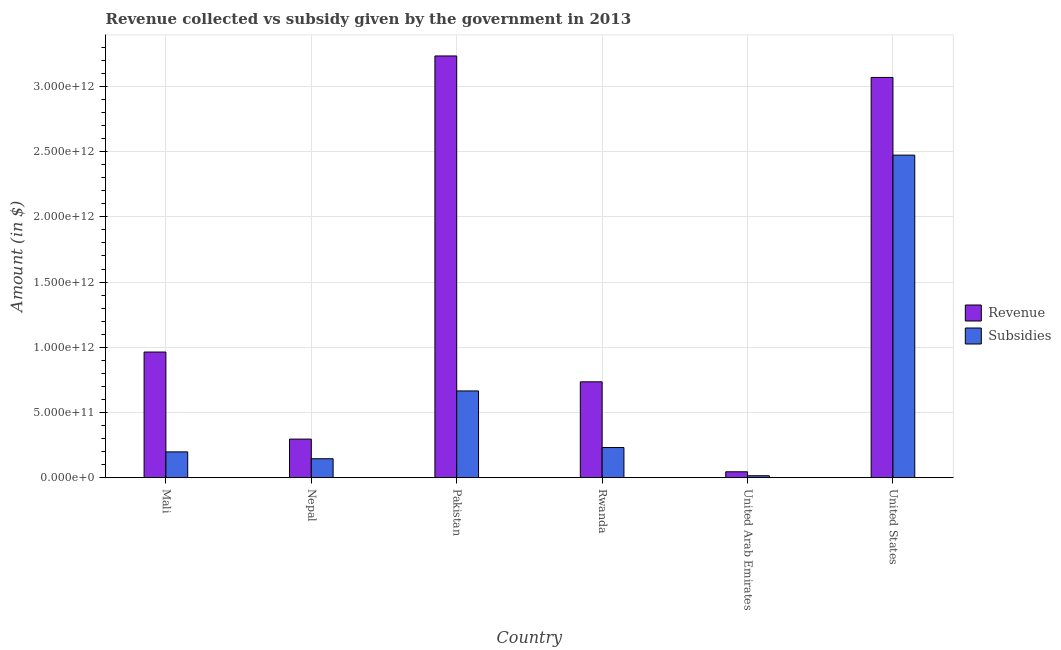How many different coloured bars are there?
Your answer should be compact. 2. How many groups of bars are there?
Ensure brevity in your answer.  6. Are the number of bars per tick equal to the number of legend labels?
Make the answer very short. Yes. Are the number of bars on each tick of the X-axis equal?
Keep it short and to the point. Yes. How many bars are there on the 1st tick from the left?
Your response must be concise. 2. How many bars are there on the 5th tick from the right?
Your answer should be very brief. 2. What is the label of the 1st group of bars from the left?
Your response must be concise. Mali. In how many cases, is the number of bars for a given country not equal to the number of legend labels?
Offer a terse response. 0. What is the amount of revenue collected in Nepal?
Your response must be concise. 2.96e+11. Across all countries, what is the maximum amount of subsidies given?
Your answer should be compact. 2.47e+12. Across all countries, what is the minimum amount of subsidies given?
Your answer should be very brief. 1.47e+1. In which country was the amount of revenue collected minimum?
Provide a short and direct response. United Arab Emirates. What is the total amount of revenue collected in the graph?
Provide a succinct answer. 8.34e+12. What is the difference between the amount of revenue collected in Mali and that in Rwanda?
Offer a terse response. 2.28e+11. What is the difference between the amount of revenue collected in Mali and the amount of subsidies given in Pakistan?
Offer a very short reply. 2.98e+11. What is the average amount of revenue collected per country?
Keep it short and to the point. 1.39e+12. What is the difference between the amount of revenue collected and amount of subsidies given in United Arab Emirates?
Ensure brevity in your answer.  3.02e+1. In how many countries, is the amount of subsidies given greater than 900000000000 $?
Ensure brevity in your answer.  1. What is the ratio of the amount of revenue collected in Pakistan to that in United Arab Emirates?
Provide a short and direct response. 72.01. Is the amount of revenue collected in Pakistan less than that in United Arab Emirates?
Provide a succinct answer. No. What is the difference between the highest and the second highest amount of subsidies given?
Ensure brevity in your answer.  1.81e+12. What is the difference between the highest and the lowest amount of revenue collected?
Ensure brevity in your answer.  3.19e+12. Is the sum of the amount of subsidies given in Nepal and United States greater than the maximum amount of revenue collected across all countries?
Make the answer very short. No. What does the 2nd bar from the left in Nepal represents?
Your answer should be very brief. Subsidies. What does the 1st bar from the right in Rwanda represents?
Ensure brevity in your answer.  Subsidies. Are all the bars in the graph horizontal?
Offer a terse response. No. What is the difference between two consecutive major ticks on the Y-axis?
Give a very brief answer. 5.00e+11. Are the values on the major ticks of Y-axis written in scientific E-notation?
Your answer should be compact. Yes. Where does the legend appear in the graph?
Ensure brevity in your answer.  Center right. How are the legend labels stacked?
Make the answer very short. Vertical. What is the title of the graph?
Make the answer very short. Revenue collected vs subsidy given by the government in 2013. Does "Domestic Liabilities" appear as one of the legend labels in the graph?
Provide a short and direct response. No. What is the label or title of the X-axis?
Your response must be concise. Country. What is the label or title of the Y-axis?
Give a very brief answer. Amount (in $). What is the Amount (in $) of Revenue in Mali?
Your answer should be very brief. 9.63e+11. What is the Amount (in $) in Subsidies in Mali?
Ensure brevity in your answer.  1.98e+11. What is the Amount (in $) of Revenue in Nepal?
Your response must be concise. 2.96e+11. What is the Amount (in $) in Subsidies in Nepal?
Give a very brief answer. 1.45e+11. What is the Amount (in $) of Revenue in Pakistan?
Provide a succinct answer. 3.23e+12. What is the Amount (in $) in Subsidies in Pakistan?
Make the answer very short. 6.65e+11. What is the Amount (in $) of Revenue in Rwanda?
Your answer should be very brief. 7.35e+11. What is the Amount (in $) in Subsidies in Rwanda?
Make the answer very short. 2.31e+11. What is the Amount (in $) in Revenue in United Arab Emirates?
Give a very brief answer. 4.49e+1. What is the Amount (in $) in Subsidies in United Arab Emirates?
Your response must be concise. 1.47e+1. What is the Amount (in $) of Revenue in United States?
Give a very brief answer. 3.07e+12. What is the Amount (in $) in Subsidies in United States?
Your response must be concise. 2.47e+12. Across all countries, what is the maximum Amount (in $) of Revenue?
Your answer should be very brief. 3.23e+12. Across all countries, what is the maximum Amount (in $) of Subsidies?
Give a very brief answer. 2.47e+12. Across all countries, what is the minimum Amount (in $) of Revenue?
Provide a short and direct response. 4.49e+1. Across all countries, what is the minimum Amount (in $) in Subsidies?
Your answer should be very brief. 1.47e+1. What is the total Amount (in $) in Revenue in the graph?
Provide a succinct answer. 8.34e+12. What is the total Amount (in $) in Subsidies in the graph?
Provide a succinct answer. 3.73e+12. What is the difference between the Amount (in $) of Revenue in Mali and that in Nepal?
Provide a succinct answer. 6.68e+11. What is the difference between the Amount (in $) in Subsidies in Mali and that in Nepal?
Offer a terse response. 5.27e+1. What is the difference between the Amount (in $) in Revenue in Mali and that in Pakistan?
Make the answer very short. -2.27e+12. What is the difference between the Amount (in $) of Subsidies in Mali and that in Pakistan?
Keep it short and to the point. -4.67e+11. What is the difference between the Amount (in $) of Revenue in Mali and that in Rwanda?
Your response must be concise. 2.28e+11. What is the difference between the Amount (in $) of Subsidies in Mali and that in Rwanda?
Provide a succinct answer. -3.32e+1. What is the difference between the Amount (in $) of Revenue in Mali and that in United Arab Emirates?
Your answer should be very brief. 9.18e+11. What is the difference between the Amount (in $) of Subsidies in Mali and that in United Arab Emirates?
Provide a short and direct response. 1.83e+11. What is the difference between the Amount (in $) of Revenue in Mali and that in United States?
Your answer should be very brief. -2.11e+12. What is the difference between the Amount (in $) of Subsidies in Mali and that in United States?
Give a very brief answer. -2.28e+12. What is the difference between the Amount (in $) in Revenue in Nepal and that in Pakistan?
Provide a succinct answer. -2.94e+12. What is the difference between the Amount (in $) in Subsidies in Nepal and that in Pakistan?
Make the answer very short. -5.20e+11. What is the difference between the Amount (in $) of Revenue in Nepal and that in Rwanda?
Offer a terse response. -4.39e+11. What is the difference between the Amount (in $) in Subsidies in Nepal and that in Rwanda?
Your answer should be very brief. -8.59e+1. What is the difference between the Amount (in $) of Revenue in Nepal and that in United Arab Emirates?
Ensure brevity in your answer.  2.51e+11. What is the difference between the Amount (in $) of Subsidies in Nepal and that in United Arab Emirates?
Your answer should be very brief. 1.30e+11. What is the difference between the Amount (in $) in Revenue in Nepal and that in United States?
Your answer should be compact. -2.77e+12. What is the difference between the Amount (in $) of Subsidies in Nepal and that in United States?
Give a very brief answer. -2.33e+12. What is the difference between the Amount (in $) in Revenue in Pakistan and that in Rwanda?
Keep it short and to the point. 2.50e+12. What is the difference between the Amount (in $) of Subsidies in Pakistan and that in Rwanda?
Give a very brief answer. 4.34e+11. What is the difference between the Amount (in $) of Revenue in Pakistan and that in United Arab Emirates?
Make the answer very short. 3.19e+12. What is the difference between the Amount (in $) in Subsidies in Pakistan and that in United Arab Emirates?
Ensure brevity in your answer.  6.50e+11. What is the difference between the Amount (in $) of Revenue in Pakistan and that in United States?
Make the answer very short. 1.65e+11. What is the difference between the Amount (in $) of Subsidies in Pakistan and that in United States?
Provide a succinct answer. -1.81e+12. What is the difference between the Amount (in $) in Revenue in Rwanda and that in United Arab Emirates?
Keep it short and to the point. 6.90e+11. What is the difference between the Amount (in $) of Subsidies in Rwanda and that in United Arab Emirates?
Keep it short and to the point. 2.16e+11. What is the difference between the Amount (in $) of Revenue in Rwanda and that in United States?
Ensure brevity in your answer.  -2.33e+12. What is the difference between the Amount (in $) of Subsidies in Rwanda and that in United States?
Your response must be concise. -2.24e+12. What is the difference between the Amount (in $) in Revenue in United Arab Emirates and that in United States?
Give a very brief answer. -3.02e+12. What is the difference between the Amount (in $) of Subsidies in United Arab Emirates and that in United States?
Your response must be concise. -2.46e+12. What is the difference between the Amount (in $) in Revenue in Mali and the Amount (in $) in Subsidies in Nepal?
Provide a short and direct response. 8.18e+11. What is the difference between the Amount (in $) of Revenue in Mali and the Amount (in $) of Subsidies in Pakistan?
Make the answer very short. 2.98e+11. What is the difference between the Amount (in $) in Revenue in Mali and the Amount (in $) in Subsidies in Rwanda?
Offer a very short reply. 7.32e+11. What is the difference between the Amount (in $) in Revenue in Mali and the Amount (in $) in Subsidies in United Arab Emirates?
Ensure brevity in your answer.  9.49e+11. What is the difference between the Amount (in $) of Revenue in Mali and the Amount (in $) of Subsidies in United States?
Offer a very short reply. -1.51e+12. What is the difference between the Amount (in $) in Revenue in Nepal and the Amount (in $) in Subsidies in Pakistan?
Keep it short and to the point. -3.69e+11. What is the difference between the Amount (in $) of Revenue in Nepal and the Amount (in $) of Subsidies in Rwanda?
Your answer should be very brief. 6.48e+1. What is the difference between the Amount (in $) in Revenue in Nepal and the Amount (in $) in Subsidies in United Arab Emirates?
Your response must be concise. 2.81e+11. What is the difference between the Amount (in $) in Revenue in Nepal and the Amount (in $) in Subsidies in United States?
Provide a short and direct response. -2.18e+12. What is the difference between the Amount (in $) of Revenue in Pakistan and the Amount (in $) of Subsidies in Rwanda?
Offer a terse response. 3.00e+12. What is the difference between the Amount (in $) of Revenue in Pakistan and the Amount (in $) of Subsidies in United Arab Emirates?
Your answer should be compact. 3.22e+12. What is the difference between the Amount (in $) in Revenue in Pakistan and the Amount (in $) in Subsidies in United States?
Provide a short and direct response. 7.61e+11. What is the difference between the Amount (in $) of Revenue in Rwanda and the Amount (in $) of Subsidies in United Arab Emirates?
Your response must be concise. 7.20e+11. What is the difference between the Amount (in $) in Revenue in Rwanda and the Amount (in $) in Subsidies in United States?
Offer a very short reply. -1.74e+12. What is the difference between the Amount (in $) in Revenue in United Arab Emirates and the Amount (in $) in Subsidies in United States?
Your answer should be compact. -2.43e+12. What is the average Amount (in $) in Revenue per country?
Offer a very short reply. 1.39e+12. What is the average Amount (in $) in Subsidies per country?
Ensure brevity in your answer.  6.21e+11. What is the difference between the Amount (in $) in Revenue and Amount (in $) in Subsidies in Mali?
Give a very brief answer. 7.66e+11. What is the difference between the Amount (in $) of Revenue and Amount (in $) of Subsidies in Nepal?
Make the answer very short. 1.51e+11. What is the difference between the Amount (in $) of Revenue and Amount (in $) of Subsidies in Pakistan?
Ensure brevity in your answer.  2.57e+12. What is the difference between the Amount (in $) of Revenue and Amount (in $) of Subsidies in Rwanda?
Your answer should be very brief. 5.04e+11. What is the difference between the Amount (in $) in Revenue and Amount (in $) in Subsidies in United Arab Emirates?
Provide a short and direct response. 3.02e+1. What is the difference between the Amount (in $) in Revenue and Amount (in $) in Subsidies in United States?
Ensure brevity in your answer.  5.96e+11. What is the ratio of the Amount (in $) in Revenue in Mali to that in Nepal?
Your response must be concise. 3.26. What is the ratio of the Amount (in $) of Subsidies in Mali to that in Nepal?
Provide a short and direct response. 1.36. What is the ratio of the Amount (in $) in Revenue in Mali to that in Pakistan?
Make the answer very short. 0.3. What is the ratio of the Amount (in $) of Subsidies in Mali to that in Pakistan?
Keep it short and to the point. 0.3. What is the ratio of the Amount (in $) in Revenue in Mali to that in Rwanda?
Your answer should be compact. 1.31. What is the ratio of the Amount (in $) of Subsidies in Mali to that in Rwanda?
Keep it short and to the point. 0.86. What is the ratio of the Amount (in $) of Revenue in Mali to that in United Arab Emirates?
Provide a succinct answer. 21.45. What is the ratio of the Amount (in $) in Subsidies in Mali to that in United Arab Emirates?
Your response must be concise. 13.45. What is the ratio of the Amount (in $) in Revenue in Mali to that in United States?
Keep it short and to the point. 0.31. What is the ratio of the Amount (in $) in Subsidies in Mali to that in United States?
Provide a short and direct response. 0.08. What is the ratio of the Amount (in $) of Revenue in Nepal to that in Pakistan?
Provide a short and direct response. 0.09. What is the ratio of the Amount (in $) in Subsidies in Nepal to that in Pakistan?
Offer a terse response. 0.22. What is the ratio of the Amount (in $) of Revenue in Nepal to that in Rwanda?
Provide a succinct answer. 0.4. What is the ratio of the Amount (in $) in Subsidies in Nepal to that in Rwanda?
Make the answer very short. 0.63. What is the ratio of the Amount (in $) in Revenue in Nepal to that in United Arab Emirates?
Your answer should be compact. 6.58. What is the ratio of the Amount (in $) in Subsidies in Nepal to that in United Arab Emirates?
Make the answer very short. 9.86. What is the ratio of the Amount (in $) in Revenue in Nepal to that in United States?
Offer a terse response. 0.1. What is the ratio of the Amount (in $) of Subsidies in Nepal to that in United States?
Provide a succinct answer. 0.06. What is the ratio of the Amount (in $) of Revenue in Pakistan to that in Rwanda?
Your answer should be very brief. 4.4. What is the ratio of the Amount (in $) in Subsidies in Pakistan to that in Rwanda?
Offer a terse response. 2.88. What is the ratio of the Amount (in $) in Revenue in Pakistan to that in United Arab Emirates?
Your response must be concise. 72.01. What is the ratio of the Amount (in $) of Subsidies in Pakistan to that in United Arab Emirates?
Offer a terse response. 45.28. What is the ratio of the Amount (in $) of Revenue in Pakistan to that in United States?
Give a very brief answer. 1.05. What is the ratio of the Amount (in $) of Subsidies in Pakistan to that in United States?
Your answer should be very brief. 0.27. What is the ratio of the Amount (in $) of Revenue in Rwanda to that in United Arab Emirates?
Your answer should be very brief. 16.36. What is the ratio of the Amount (in $) of Subsidies in Rwanda to that in United Arab Emirates?
Offer a terse response. 15.71. What is the ratio of the Amount (in $) of Revenue in Rwanda to that in United States?
Provide a succinct answer. 0.24. What is the ratio of the Amount (in $) of Subsidies in Rwanda to that in United States?
Offer a terse response. 0.09. What is the ratio of the Amount (in $) of Revenue in United Arab Emirates to that in United States?
Your response must be concise. 0.01. What is the ratio of the Amount (in $) in Subsidies in United Arab Emirates to that in United States?
Your answer should be compact. 0.01. What is the difference between the highest and the second highest Amount (in $) of Revenue?
Provide a succinct answer. 1.65e+11. What is the difference between the highest and the second highest Amount (in $) in Subsidies?
Make the answer very short. 1.81e+12. What is the difference between the highest and the lowest Amount (in $) in Revenue?
Make the answer very short. 3.19e+12. What is the difference between the highest and the lowest Amount (in $) in Subsidies?
Your response must be concise. 2.46e+12. 